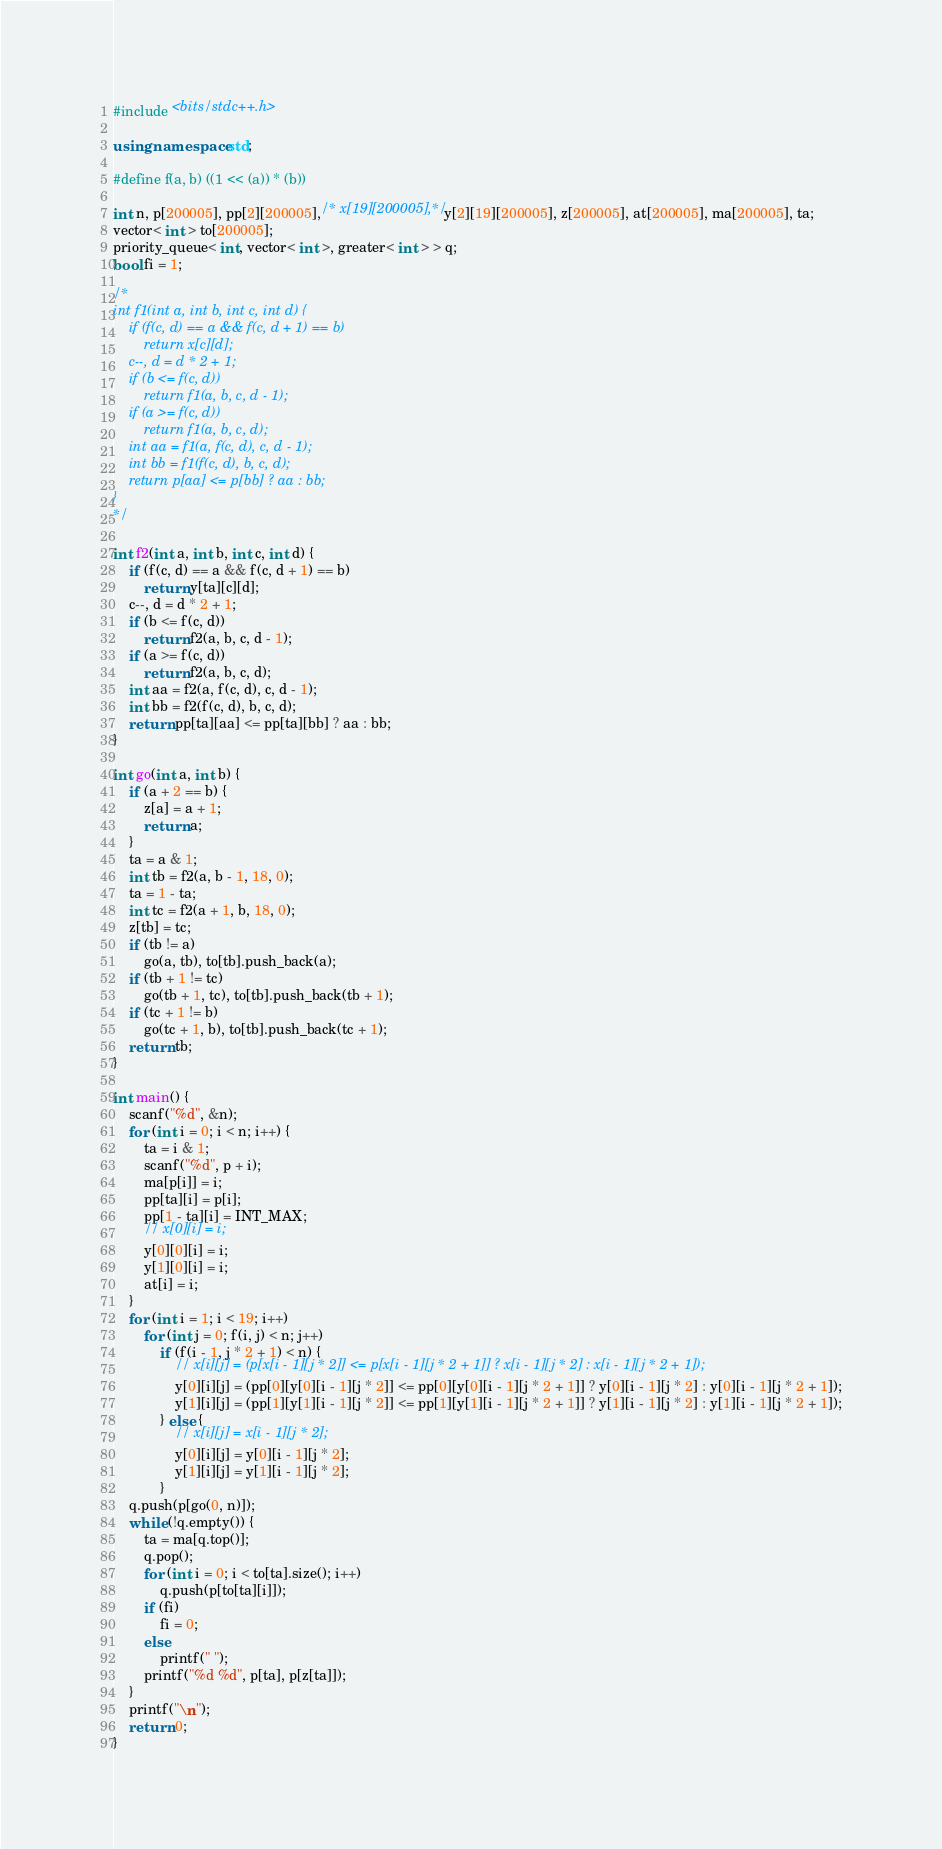Convert code to text. <code><loc_0><loc_0><loc_500><loc_500><_C++_>#include <bits/stdc++.h>

using namespace std;

#define f(a, b) ((1 << (a)) * (b))

int n, p[200005], pp[2][200005],/* x[19][200005],*/ y[2][19][200005], z[200005], at[200005], ma[200005], ta;
vector< int > to[200005];
priority_queue< int, vector< int >, greater< int > > q;
bool fi = 1;

/*
int f1(int a, int b, int c, int d) {
	if (f(c, d) == a && f(c, d + 1) == b)
		return x[c][d];
	c--, d = d * 2 + 1;
	if (b <= f(c, d))
		return f1(a, b, c, d - 1);
	if (a >= f(c, d))
		return f1(a, b, c, d);
	int aa = f1(a, f(c, d), c, d - 1);
	int bb = f1(f(c, d), b, c, d);
	return p[aa] <= p[bb] ? aa : bb;
}
*/

int f2(int a, int b, int c, int d) {
	if (f(c, d) == a && f(c, d + 1) == b)
		return y[ta][c][d];
	c--, d = d * 2 + 1;
	if (b <= f(c, d))
		return f2(a, b, c, d - 1);
	if (a >= f(c, d))
		return f2(a, b, c, d);
	int aa = f2(a, f(c, d), c, d - 1);
	int bb = f2(f(c, d), b, c, d);
	return pp[ta][aa] <= pp[ta][bb] ? aa : bb;
}

int go(int a, int b) {
	if (a + 2 == b) {
		z[a] = a + 1;
		return a;
	}
	ta = a & 1;
	int tb = f2(a, b - 1, 18, 0);
	ta = 1 - ta;
	int tc = f2(a + 1, b, 18, 0);
	z[tb] = tc;
	if (tb != a)
		go(a, tb), to[tb].push_back(a);
	if (tb + 1 != tc)
		go(tb + 1, tc), to[tb].push_back(tb + 1);
	if (tc + 1 != b)
		go(tc + 1, b), to[tb].push_back(tc + 1);
	return tb;
}

int main() {
	scanf("%d", &n);
	for (int i = 0; i < n; i++) {
		ta = i & 1;
		scanf("%d", p + i);
		ma[p[i]] = i;
		pp[ta][i] = p[i];
		pp[1 - ta][i] = INT_MAX;
		// x[0][i] = i;
		y[0][0][i] = i;
		y[1][0][i] = i;
		at[i] = i;
	}
	for (int i = 1; i < 19; i++)
		for (int j = 0; f(i, j) < n; j++)
			if (f(i - 1, j * 2 + 1) < n) {
				// x[i][j] = (p[x[i - 1][j * 2]] <= p[x[i - 1][j * 2 + 1]] ? x[i - 1][j * 2] : x[i - 1][j * 2 + 1]);
				y[0][i][j] = (pp[0][y[0][i - 1][j * 2]] <= pp[0][y[0][i - 1][j * 2 + 1]] ? y[0][i - 1][j * 2] : y[0][i - 1][j * 2 + 1]);
				y[1][i][j] = (pp[1][y[1][i - 1][j * 2]] <= pp[1][y[1][i - 1][j * 2 + 1]] ? y[1][i - 1][j * 2] : y[1][i - 1][j * 2 + 1]);
			} else {
				// x[i][j] = x[i - 1][j * 2];
				y[0][i][j] = y[0][i - 1][j * 2];
				y[1][i][j] = y[1][i - 1][j * 2];
			}
	q.push(p[go(0, n)]);
	while (!q.empty()) {
		ta = ma[q.top()];
		q.pop();
		for (int i = 0; i < to[ta].size(); i++)
			q.push(p[to[ta][i]]);
		if (fi)
			fi = 0;
		else
			printf(" ");
		printf("%d %d", p[ta], p[z[ta]]);
	}
	printf("\n");
	return 0;
}</code> 